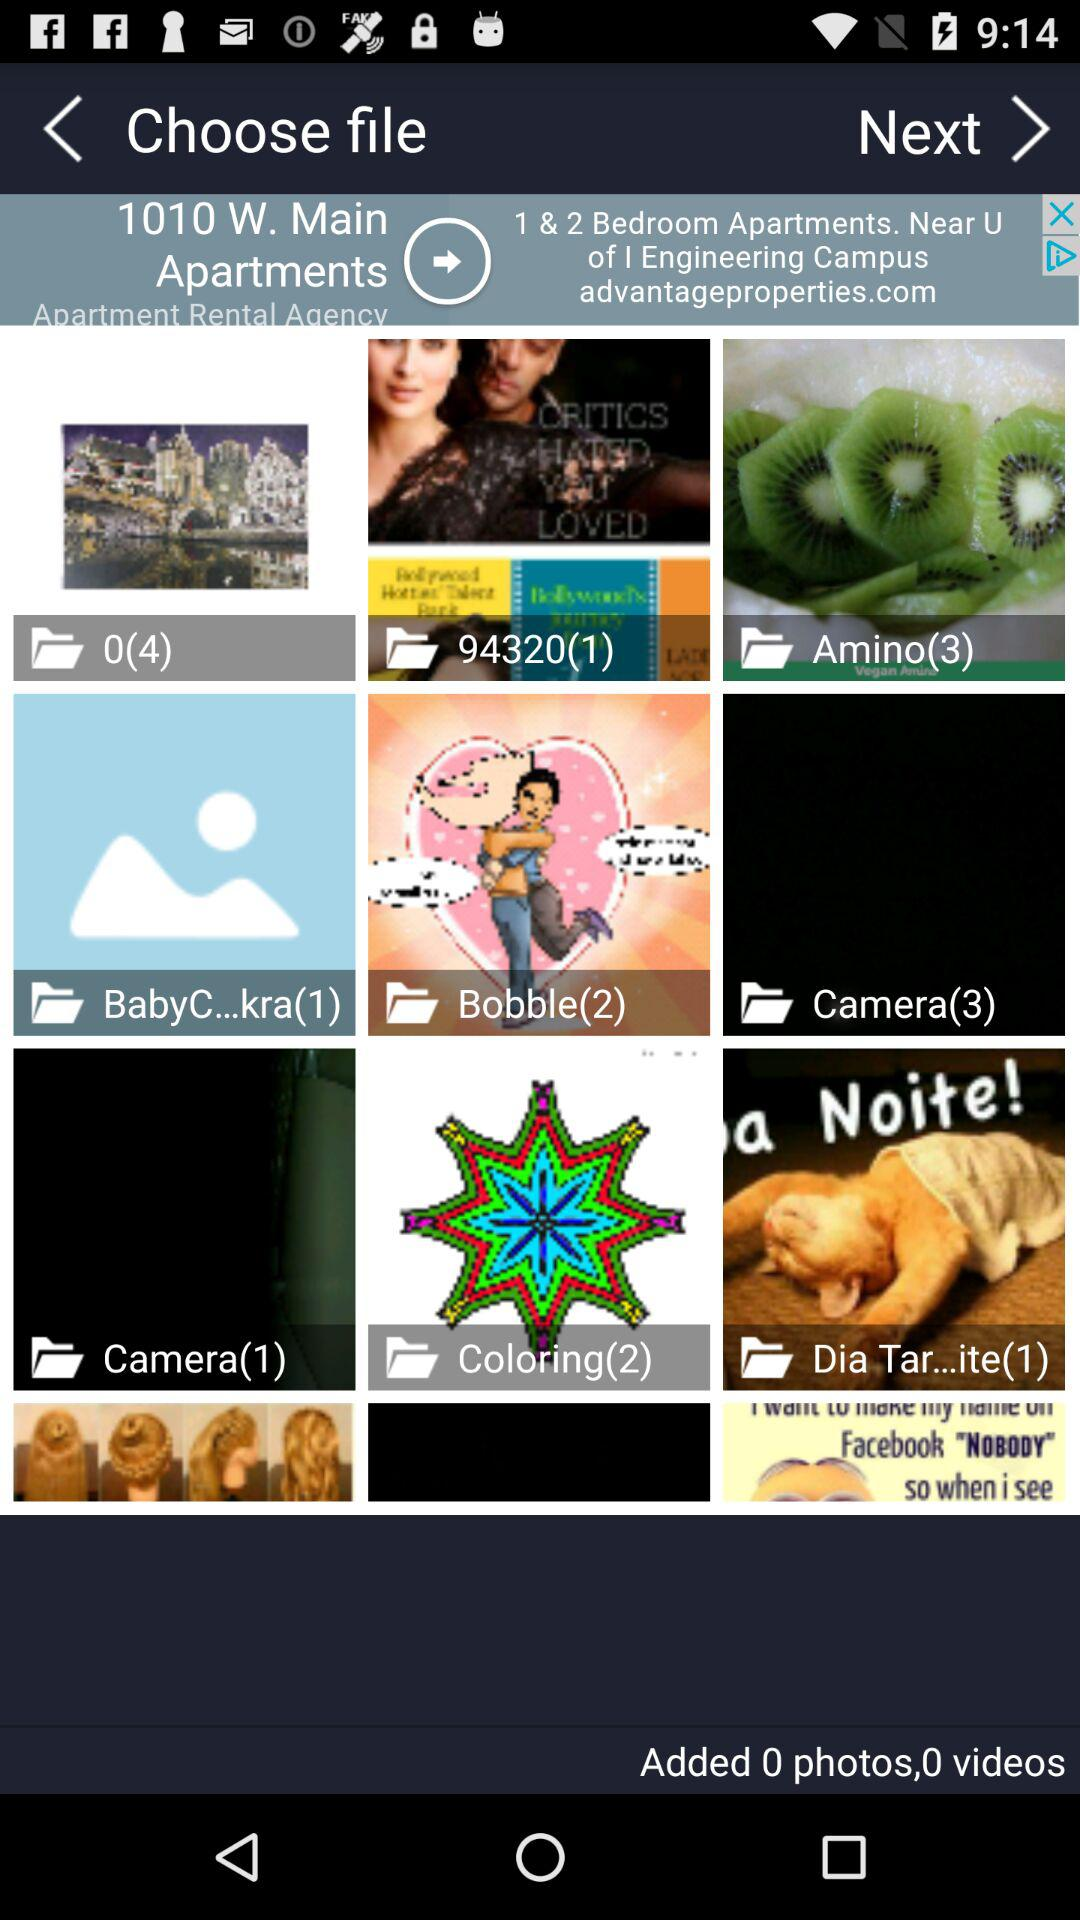What is the number of images in the "94320" folder? The number of images in the "94320" folder is 1. 